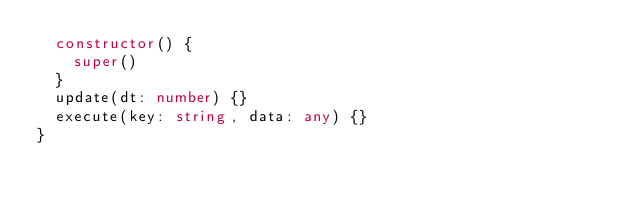<code> <loc_0><loc_0><loc_500><loc_500><_TypeScript_>  constructor() {
    super()
  }
  update(dt: number) {}
  execute(key: string, data: any) {}
}
</code> 